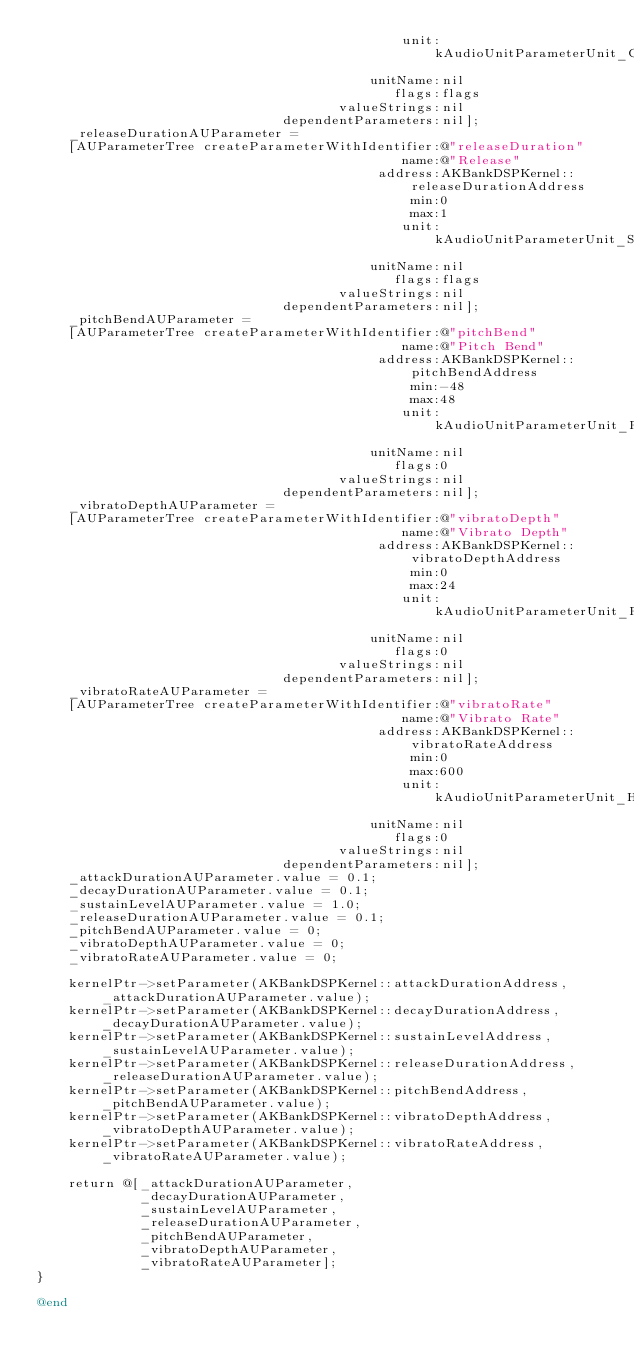Convert code to text. <code><loc_0><loc_0><loc_500><loc_500><_ObjectiveC_>                                              unit:kAudioUnitParameterUnit_Generic
                                          unitName:nil
                                             flags:flags
                                      valueStrings:nil
                               dependentParameters:nil];
    _releaseDurationAUParameter =
    [AUParameterTree createParameterWithIdentifier:@"releaseDuration"
                                              name:@"Release"
                                           address:AKBankDSPKernel::releaseDurationAddress
                                               min:0
                                               max:1
                                              unit:kAudioUnitParameterUnit_Seconds
                                          unitName:nil
                                             flags:flags
                                      valueStrings:nil
                               dependentParameters:nil];
    _pitchBendAUParameter =
    [AUParameterTree createParameterWithIdentifier:@"pitchBend"
                                              name:@"Pitch Bend"
                                           address:AKBankDSPKernel::pitchBendAddress
                                               min:-48
                                               max:48
                                              unit:kAudioUnitParameterUnit_RelativeSemiTones
                                          unitName:nil
                                             flags:0
                                      valueStrings:nil
                               dependentParameters:nil];
    _vibratoDepthAUParameter =
    [AUParameterTree createParameterWithIdentifier:@"vibratoDepth"
                                              name:@"Vibrato Depth"
                                           address:AKBankDSPKernel::vibratoDepthAddress
                                               min:0
                                               max:24
                                              unit:kAudioUnitParameterUnit_RelativeSemiTones
                                          unitName:nil
                                             flags:0
                                      valueStrings:nil
                               dependentParameters:nil];
    _vibratoRateAUParameter =
    [AUParameterTree createParameterWithIdentifier:@"vibratoRate"
                                              name:@"Vibrato Rate"
                                           address:AKBankDSPKernel::vibratoRateAddress
                                               min:0
                                               max:600
                                              unit:kAudioUnitParameterUnit_Hertz
                                          unitName:nil
                                             flags:0
                                      valueStrings:nil
                               dependentParameters:nil];
    _attackDurationAUParameter.value = 0.1;
    _decayDurationAUParameter.value = 0.1;
    _sustainLevelAUParameter.value = 1.0;
    _releaseDurationAUParameter.value = 0.1;
    _pitchBendAUParameter.value = 0;
    _vibratoDepthAUParameter.value = 0;
    _vibratoRateAUParameter.value = 0;

    kernelPtr->setParameter(AKBankDSPKernel::attackDurationAddress,  _attackDurationAUParameter.value);
    kernelPtr->setParameter(AKBankDSPKernel::decayDurationAddress,   _decayDurationAUParameter.value);
    kernelPtr->setParameter(AKBankDSPKernel::sustainLevelAddress,    _sustainLevelAUParameter.value);
    kernelPtr->setParameter(AKBankDSPKernel::releaseDurationAddress, _releaseDurationAUParameter.value);
    kernelPtr->setParameter(AKBankDSPKernel::pitchBendAddress,       _pitchBendAUParameter.value);
    kernelPtr->setParameter(AKBankDSPKernel::vibratoDepthAddress,    _vibratoDepthAUParameter.value);
    kernelPtr->setParameter(AKBankDSPKernel::vibratoRateAddress,     _vibratoRateAUParameter.value);

    return @[_attackDurationAUParameter,
             _decayDurationAUParameter,
             _sustainLevelAUParameter,
             _releaseDurationAUParameter,
             _pitchBendAUParameter,
             _vibratoDepthAUParameter,
             _vibratoRateAUParameter];
}

@end
</code> 